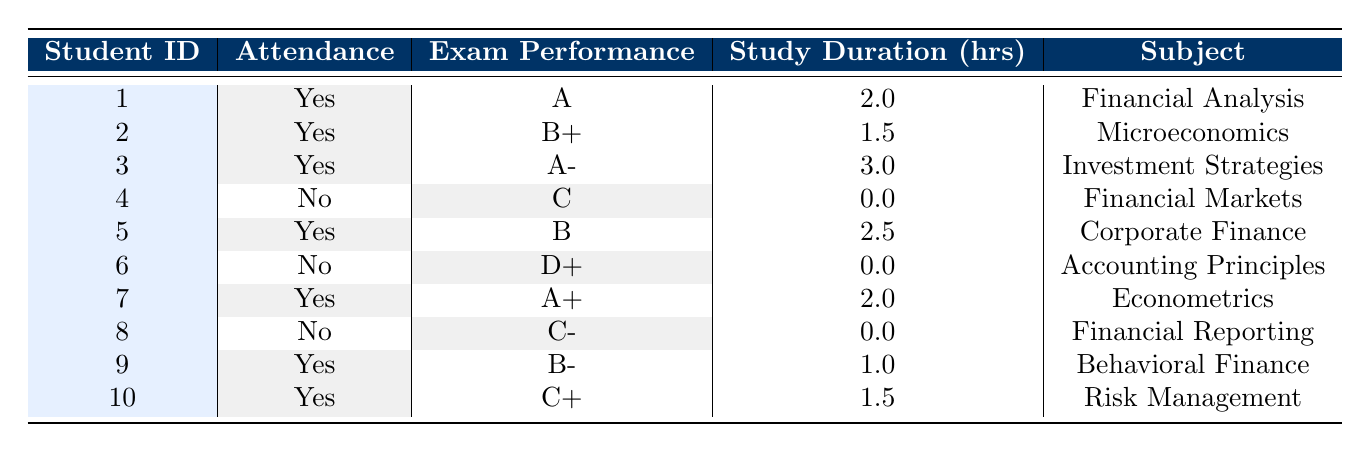What is the exam performance of student 1? Student 1's data shows an exam performance marked as "A". This information can be directly found in the table corresponding to student 1.
Answer: A How many students attended the study sessions? By reviewing the attendance column, we can see that students 1, 2, 3, 5, 7, 9, and 10 attended the study sessions. This results in 7 students attending.
Answer: 7 What is the study session duration of student 3? The table indicates that the study session duration for student 3 is listed as 3.0 hours. This information is directly visible in the corresponding row of the table.
Answer: 3.0 What is the average grade of students who attended the study sessions? The grades for attending students are A, B+, A-, B, A+, B-, and C+. Converting them to numerical values (A=4.0, B+=3.5, A-=3.7, B=3.0, A+=4.0, B-=2.7, C+=2.3) yields (4.0 + 3.5 + 3.7 + 3.0 + 4.0 + 2.7 + 2.3 = 23.2). There are 7 students, so the average is 23.2 / 7 = 3.31.
Answer: 3.31 Is it true that every student who did not attend the study sessions scored below a C? Observing students 4, 6, and 8, we find their scores are C, D+, and C-. Since all these scores are below a C, the statement is true.
Answer: Yes What is the total study session duration for students who attended? The durations for attending students are 2.0, 1.5, 3.0, 2.5, 2.0, 1.0, and 1.5 hours. Adding these together gives (2.0 + 1.5 + 3.0 + 2.5 + 2.0 + 1.0 + 1.5 = 13.5) hours.
Answer: 13.5 Which subject had the highest exam performance among attendees? The highest performance among attendees is "A+" from student 7, who studied Econometrics. This can be found by checking each student's exam performance where attendance is marked yes.
Answer: Econometrics Are there any students who scored below a B who did attend the study sessions? Looking at the grades for students who attended (A, B+, A-, B, A+, B-, C+), we see that the scores C+ (from student 10) is below a B. Hence, at least one student did score below a B.
Answer: Yes How many students scored a grade higher than B who attended the sessions? The grades higher than B among attendees are A, B+, A-, A+, which corresponds to students 1, 2, 3, and 7. Counting these results in 4 students.
Answer: 4 